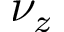Convert formula to latex. <formula><loc_0><loc_0><loc_500><loc_500>\nu _ { z }</formula> 